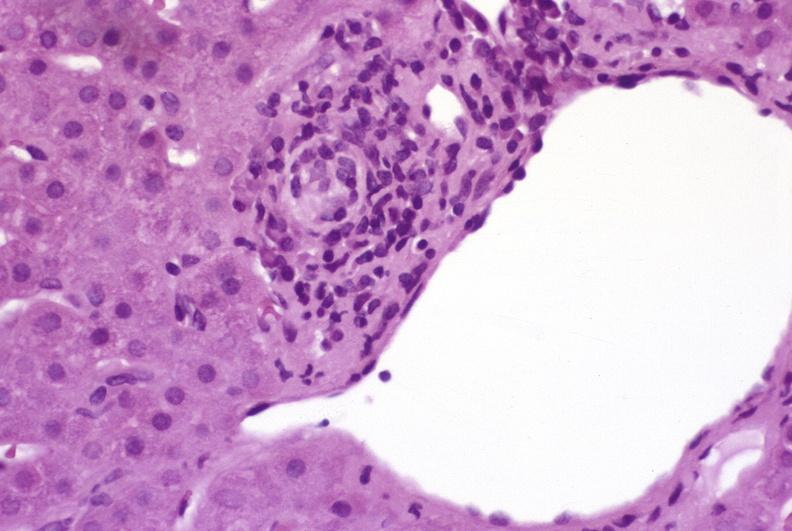s liver present?
Answer the question using a single word or phrase. Yes 